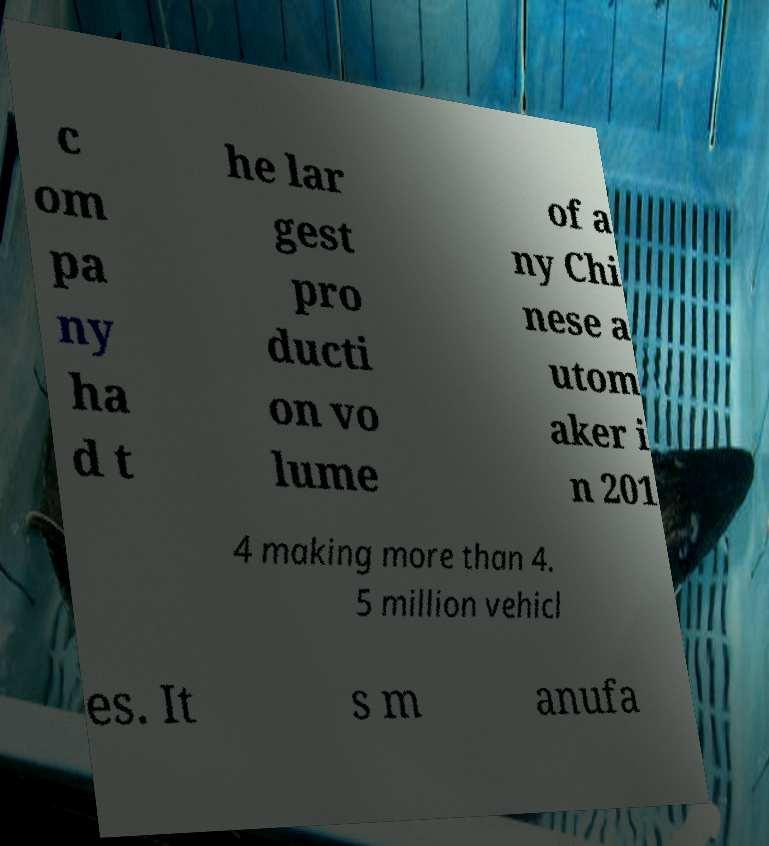For documentation purposes, I need the text within this image transcribed. Could you provide that? c om pa ny ha d t he lar gest pro ducti on vo lume of a ny Chi nese a utom aker i n 201 4 making more than 4. 5 million vehicl es. It s m anufa 